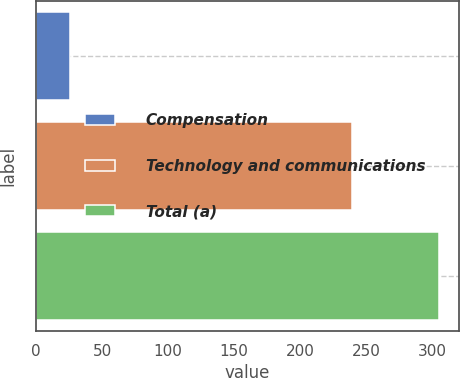Convert chart to OTSL. <chart><loc_0><loc_0><loc_500><loc_500><bar_chart><fcel>Compensation<fcel>Technology and communications<fcel>Total (a)<nl><fcel>26<fcel>239<fcel>305<nl></chart> 